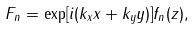<formula> <loc_0><loc_0><loc_500><loc_500>F _ { n } = \exp [ i ( k _ { x } x + k _ { y } y ) ] f _ { n } ( z ) ,</formula> 